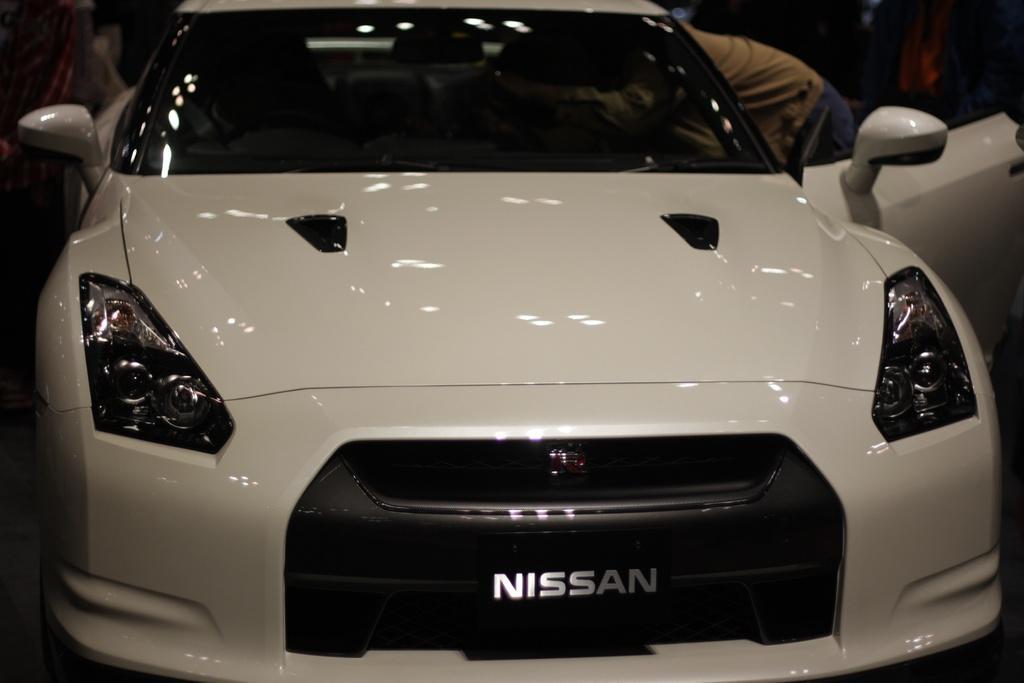Could you give a brief overview of what you see in this image? In the image there is a car and on the right side a person is peeping into the car. 